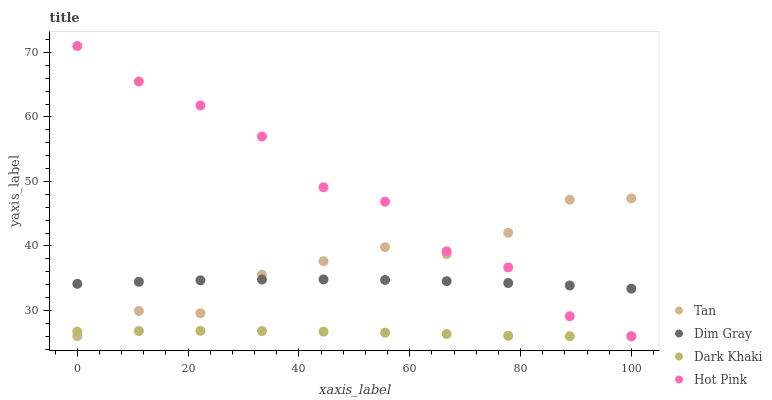Does Dark Khaki have the minimum area under the curve?
Answer yes or no. Yes. Does Hot Pink have the maximum area under the curve?
Answer yes or no. Yes. Does Tan have the minimum area under the curve?
Answer yes or no. No. Does Tan have the maximum area under the curve?
Answer yes or no. No. Is Dark Khaki the smoothest?
Answer yes or no. Yes. Is Hot Pink the roughest?
Answer yes or no. Yes. Is Tan the smoothest?
Answer yes or no. No. Is Tan the roughest?
Answer yes or no. No. Does Dark Khaki have the lowest value?
Answer yes or no. Yes. Does Dim Gray have the lowest value?
Answer yes or no. No. Does Hot Pink have the highest value?
Answer yes or no. Yes. Does Tan have the highest value?
Answer yes or no. No. Is Dark Khaki less than Dim Gray?
Answer yes or no. Yes. Is Dim Gray greater than Dark Khaki?
Answer yes or no. Yes. Does Tan intersect Dim Gray?
Answer yes or no. Yes. Is Tan less than Dim Gray?
Answer yes or no. No. Is Tan greater than Dim Gray?
Answer yes or no. No. Does Dark Khaki intersect Dim Gray?
Answer yes or no. No. 